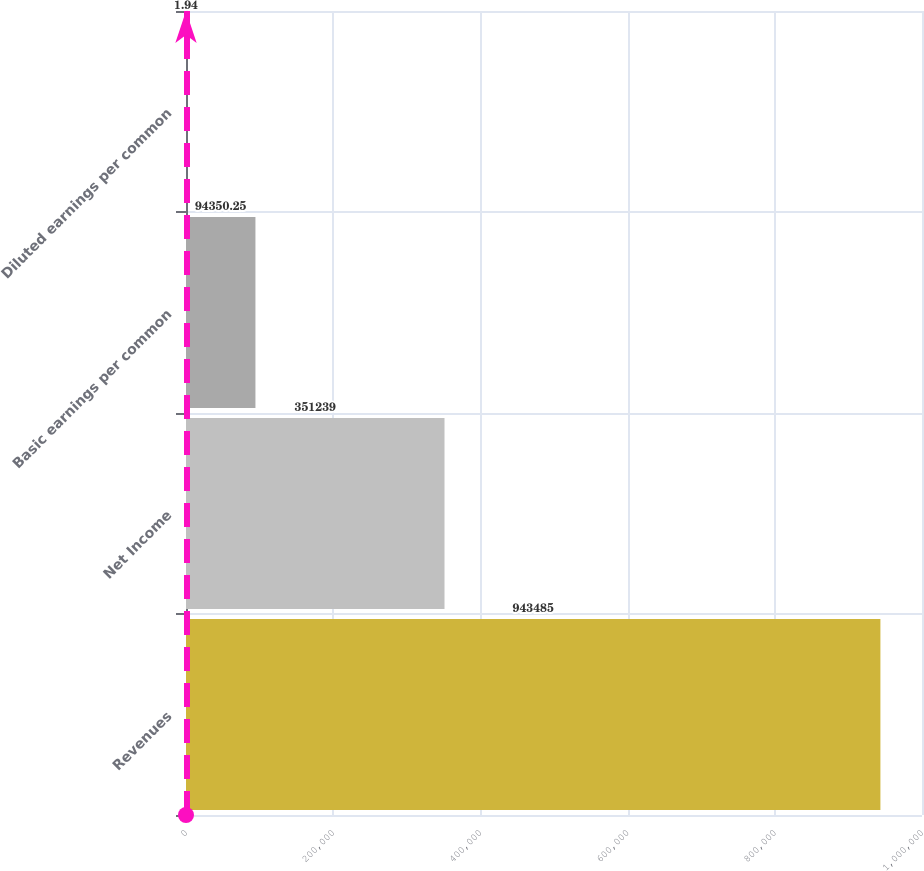Convert chart to OTSL. <chart><loc_0><loc_0><loc_500><loc_500><bar_chart><fcel>Revenues<fcel>Net Income<fcel>Basic earnings per common<fcel>Diluted earnings per common<nl><fcel>943485<fcel>351239<fcel>94350.2<fcel>1.94<nl></chart> 